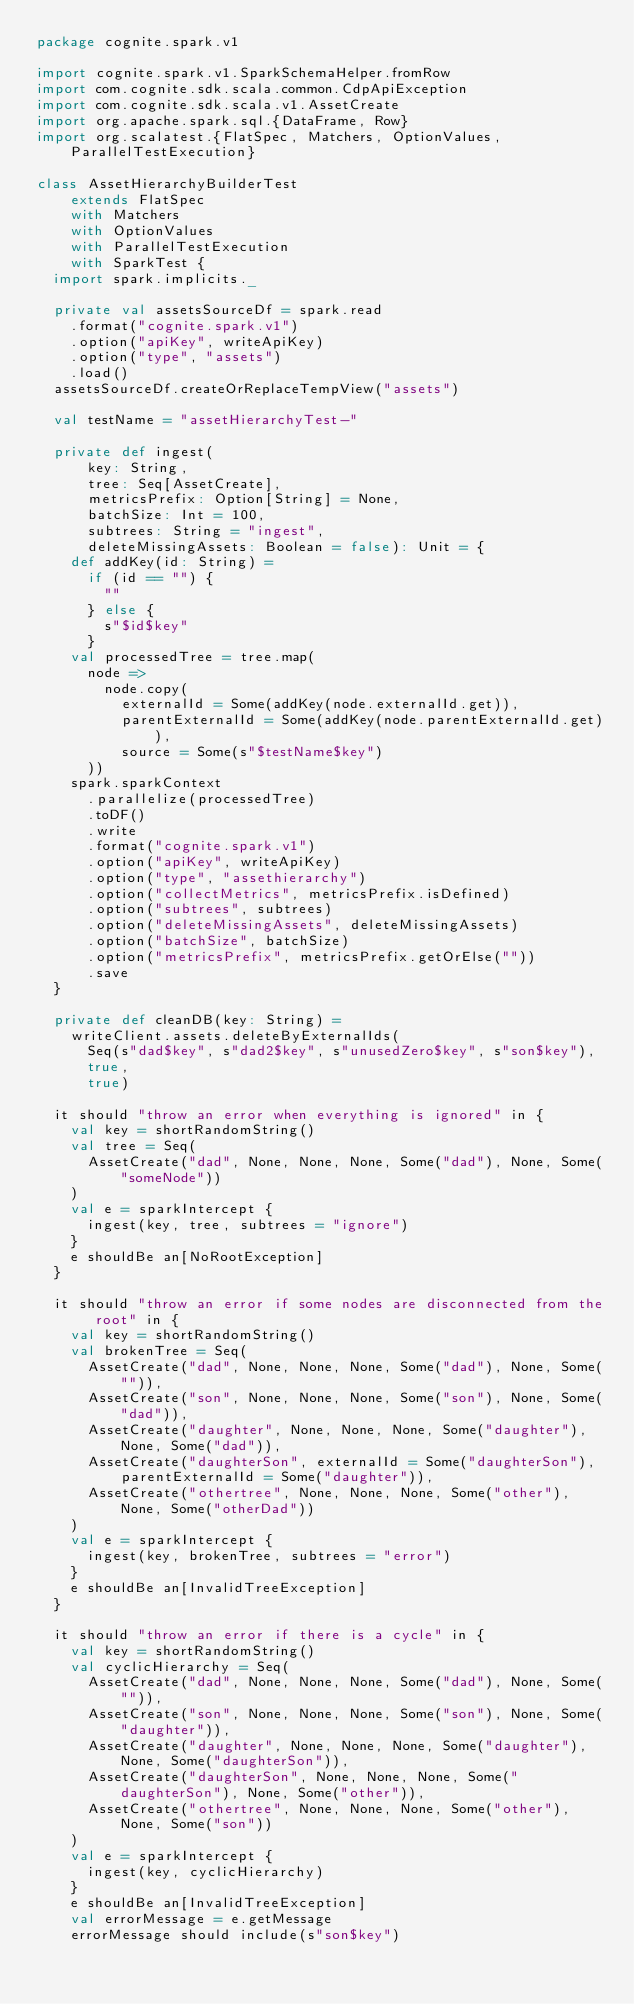Convert code to text. <code><loc_0><loc_0><loc_500><loc_500><_Scala_>package cognite.spark.v1

import cognite.spark.v1.SparkSchemaHelper.fromRow
import com.cognite.sdk.scala.common.CdpApiException
import com.cognite.sdk.scala.v1.AssetCreate
import org.apache.spark.sql.{DataFrame, Row}
import org.scalatest.{FlatSpec, Matchers, OptionValues, ParallelTestExecution}

class AssetHierarchyBuilderTest
    extends FlatSpec
    with Matchers
    with OptionValues
    with ParallelTestExecution
    with SparkTest {
  import spark.implicits._

  private val assetsSourceDf = spark.read
    .format("cognite.spark.v1")
    .option("apiKey", writeApiKey)
    .option("type", "assets")
    .load()
  assetsSourceDf.createOrReplaceTempView("assets")

  val testName = "assetHierarchyTest-"

  private def ingest(
      key: String,
      tree: Seq[AssetCreate],
      metricsPrefix: Option[String] = None,
      batchSize: Int = 100,
      subtrees: String = "ingest",
      deleteMissingAssets: Boolean = false): Unit = {
    def addKey(id: String) =
      if (id == "") {
        ""
      } else {
        s"$id$key"
      }
    val processedTree = tree.map(
      node =>
        node.copy(
          externalId = Some(addKey(node.externalId.get)),
          parentExternalId = Some(addKey(node.parentExternalId.get)),
          source = Some(s"$testName$key")
      ))
    spark.sparkContext
      .parallelize(processedTree)
      .toDF()
      .write
      .format("cognite.spark.v1")
      .option("apiKey", writeApiKey)
      .option("type", "assethierarchy")
      .option("collectMetrics", metricsPrefix.isDefined)
      .option("subtrees", subtrees)
      .option("deleteMissingAssets", deleteMissingAssets)
      .option("batchSize", batchSize)
      .option("metricsPrefix", metricsPrefix.getOrElse(""))
      .save
  }

  private def cleanDB(key: String) =
    writeClient.assets.deleteByExternalIds(
      Seq(s"dad$key", s"dad2$key", s"unusedZero$key", s"son$key"),
      true,
      true)

  it should "throw an error when everything is ignored" in {
    val key = shortRandomString()
    val tree = Seq(
      AssetCreate("dad", None, None, None, Some("dad"), None, Some("someNode"))
    )
    val e = sparkIntercept {
      ingest(key, tree, subtrees = "ignore")
    }
    e shouldBe an[NoRootException]
  }

  it should "throw an error if some nodes are disconnected from the root" in {
    val key = shortRandomString()
    val brokenTree = Seq(
      AssetCreate("dad", None, None, None, Some("dad"), None, Some("")),
      AssetCreate("son", None, None, None, Some("son"), None, Some("dad")),
      AssetCreate("daughter", None, None, None, Some("daughter"), None, Some("dad")),
      AssetCreate("daughterSon", externalId = Some("daughterSon"), parentExternalId = Some("daughter")),
      AssetCreate("othertree", None, None, None, Some("other"), None, Some("otherDad"))
    )
    val e = sparkIntercept {
      ingest(key, brokenTree, subtrees = "error")
    }
    e shouldBe an[InvalidTreeException]
  }

  it should "throw an error if there is a cycle" in {
    val key = shortRandomString()
    val cyclicHierarchy = Seq(
      AssetCreate("dad", None, None, None, Some("dad"), None, Some("")),
      AssetCreate("son", None, None, None, Some("son"), None, Some("daughter")),
      AssetCreate("daughter", None, None, None, Some("daughter"), None, Some("daughterSon")),
      AssetCreate("daughterSon", None, None, None, Some("daughterSon"), None, Some("other")),
      AssetCreate("othertree", None, None, None, Some("other"), None, Some("son"))
    )
    val e = sparkIntercept {
      ingest(key, cyclicHierarchy)
    }
    e shouldBe an[InvalidTreeException]
    val errorMessage = e.getMessage
    errorMessage should include(s"son$key")</code> 